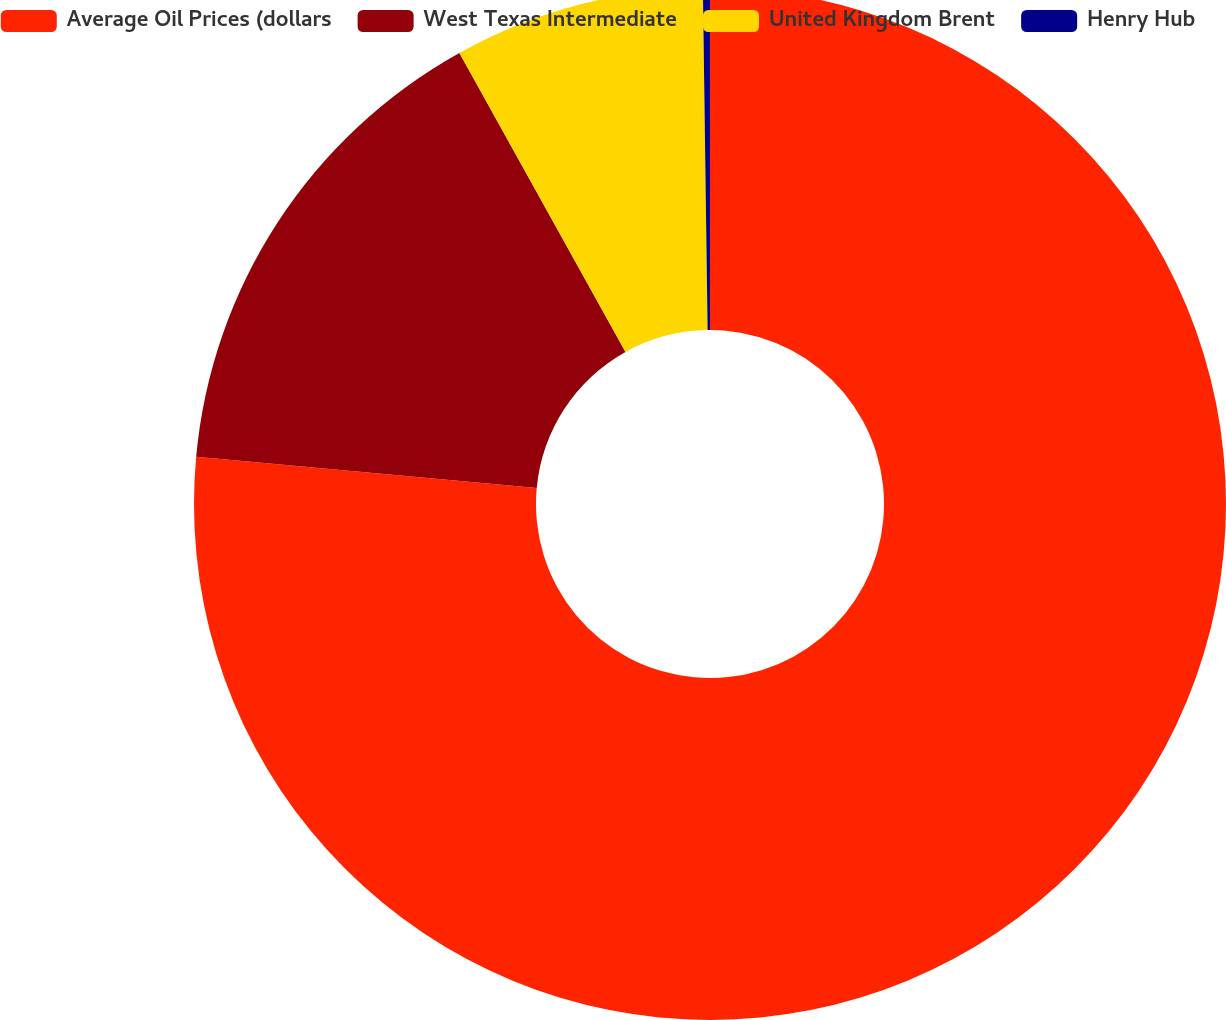Convert chart. <chart><loc_0><loc_0><loc_500><loc_500><pie_chart><fcel>Average Oil Prices (dollars<fcel>West Texas Intermediate<fcel>United Kingdom Brent<fcel>Henry Hub<nl><fcel>76.46%<fcel>15.47%<fcel>7.85%<fcel>0.22%<nl></chart> 